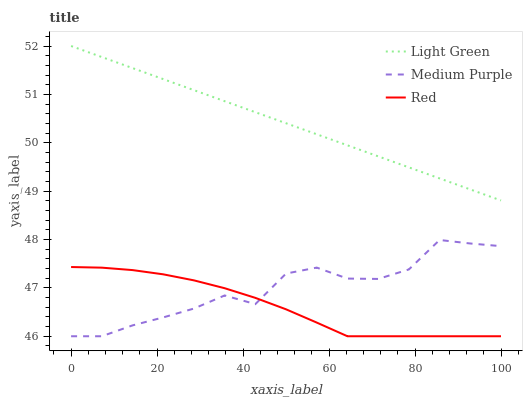Does Red have the minimum area under the curve?
Answer yes or no. Yes. Does Light Green have the maximum area under the curve?
Answer yes or no. Yes. Does Light Green have the minimum area under the curve?
Answer yes or no. No. Does Red have the maximum area under the curve?
Answer yes or no. No. Is Light Green the smoothest?
Answer yes or no. Yes. Is Medium Purple the roughest?
Answer yes or no. Yes. Is Red the smoothest?
Answer yes or no. No. Is Red the roughest?
Answer yes or no. No. Does Medium Purple have the lowest value?
Answer yes or no. Yes. Does Light Green have the lowest value?
Answer yes or no. No. Does Light Green have the highest value?
Answer yes or no. Yes. Does Red have the highest value?
Answer yes or no. No. Is Medium Purple less than Light Green?
Answer yes or no. Yes. Is Light Green greater than Medium Purple?
Answer yes or no. Yes. Does Red intersect Medium Purple?
Answer yes or no. Yes. Is Red less than Medium Purple?
Answer yes or no. No. Is Red greater than Medium Purple?
Answer yes or no. No. Does Medium Purple intersect Light Green?
Answer yes or no. No. 